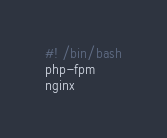<code> <loc_0><loc_0><loc_500><loc_500><_Bash_>#! /bin/bash
php-fpm
nginx</code> 